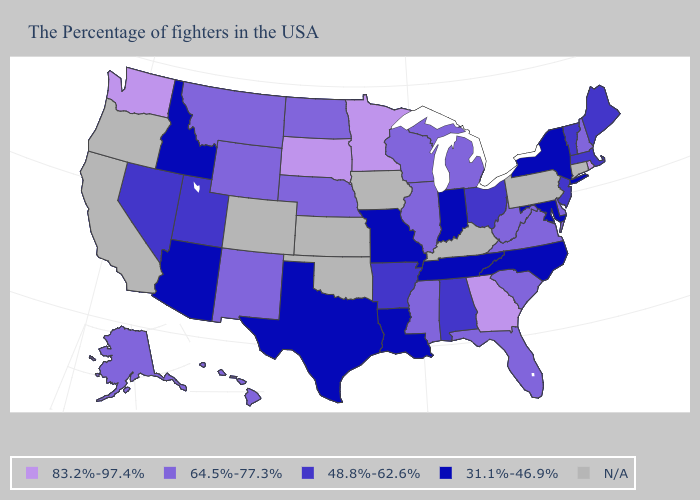Name the states that have a value in the range 48.8%-62.6%?
Keep it brief. Maine, Massachusetts, Vermont, New Jersey, Ohio, Alabama, Arkansas, Utah, Nevada. What is the highest value in the Northeast ?
Write a very short answer. 83.2%-97.4%. Name the states that have a value in the range 48.8%-62.6%?
Answer briefly. Maine, Massachusetts, Vermont, New Jersey, Ohio, Alabama, Arkansas, Utah, Nevada. What is the highest value in the USA?
Be succinct. 83.2%-97.4%. Name the states that have a value in the range 48.8%-62.6%?
Short answer required. Maine, Massachusetts, Vermont, New Jersey, Ohio, Alabama, Arkansas, Utah, Nevada. What is the lowest value in the USA?
Concise answer only. 31.1%-46.9%. Name the states that have a value in the range 48.8%-62.6%?
Give a very brief answer. Maine, Massachusetts, Vermont, New Jersey, Ohio, Alabama, Arkansas, Utah, Nevada. What is the highest value in the USA?
Keep it brief. 83.2%-97.4%. Name the states that have a value in the range 31.1%-46.9%?
Give a very brief answer. New York, Maryland, North Carolina, Indiana, Tennessee, Louisiana, Missouri, Texas, Arizona, Idaho. Does New York have the highest value in the USA?
Give a very brief answer. No. Is the legend a continuous bar?
Answer briefly. No. How many symbols are there in the legend?
Answer briefly. 5. What is the lowest value in the USA?
Short answer required. 31.1%-46.9%. Which states have the lowest value in the MidWest?
Answer briefly. Indiana, Missouri. How many symbols are there in the legend?
Answer briefly. 5. 